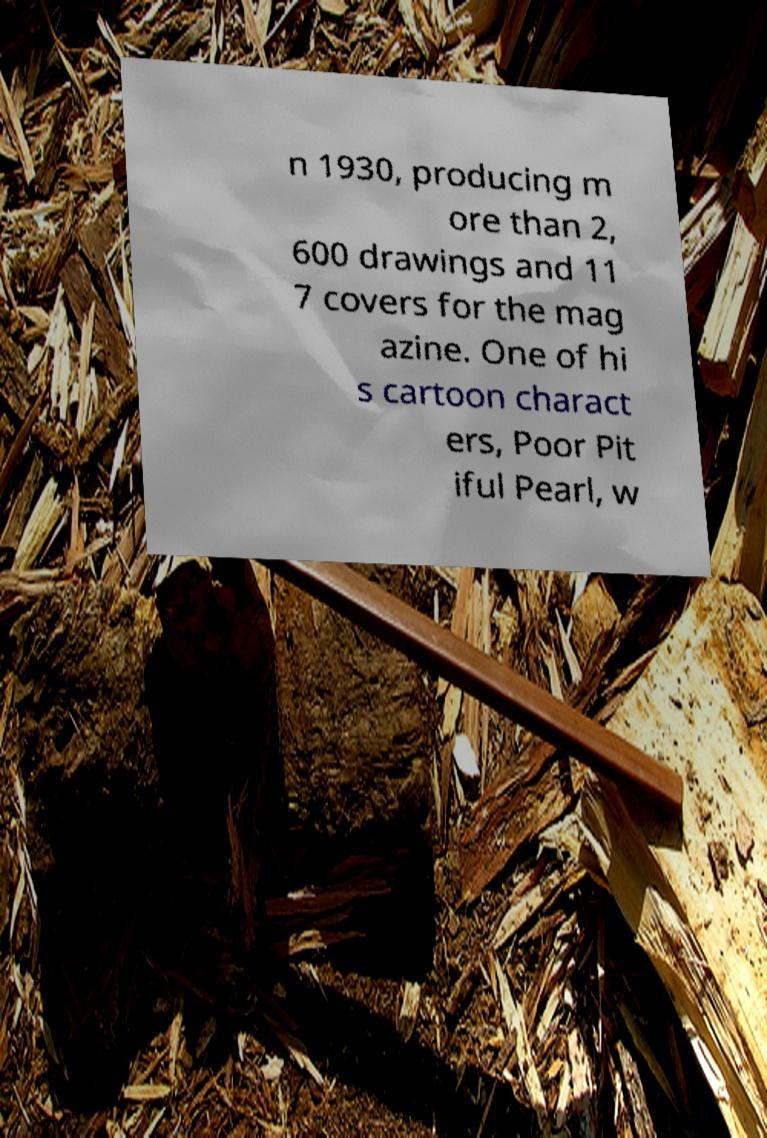Could you extract and type out the text from this image? n 1930, producing m ore than 2, 600 drawings and 11 7 covers for the mag azine. One of hi s cartoon charact ers, Poor Pit iful Pearl, w 